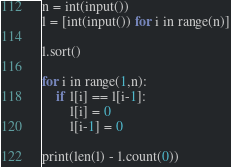Convert code to text. <code><loc_0><loc_0><loc_500><loc_500><_Python_>n = int(input())
l = [int(input()) for i in range(n)]

l.sort()

for i in range(1,n):
    if l[i] == l[i-1]:
        l[i] = 0
        l[i-1] = 0

print(len(l) - l.count(0))</code> 